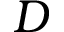Convert formula to latex. <formula><loc_0><loc_0><loc_500><loc_500>D</formula> 